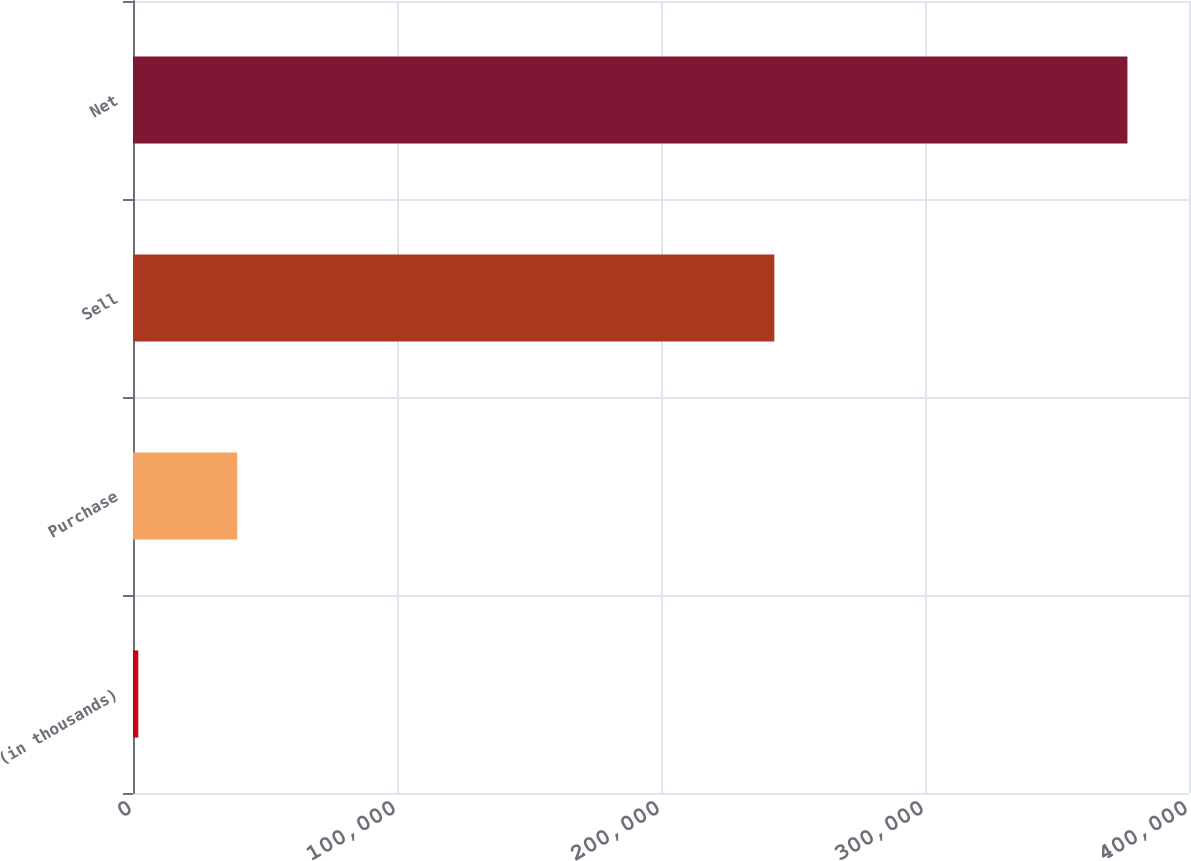Convert chart to OTSL. <chart><loc_0><loc_0><loc_500><loc_500><bar_chart><fcel>(in thousands)<fcel>Purchase<fcel>Sell<fcel>Net<nl><fcel>2007<fcel>39474<fcel>242942<fcel>376677<nl></chart> 